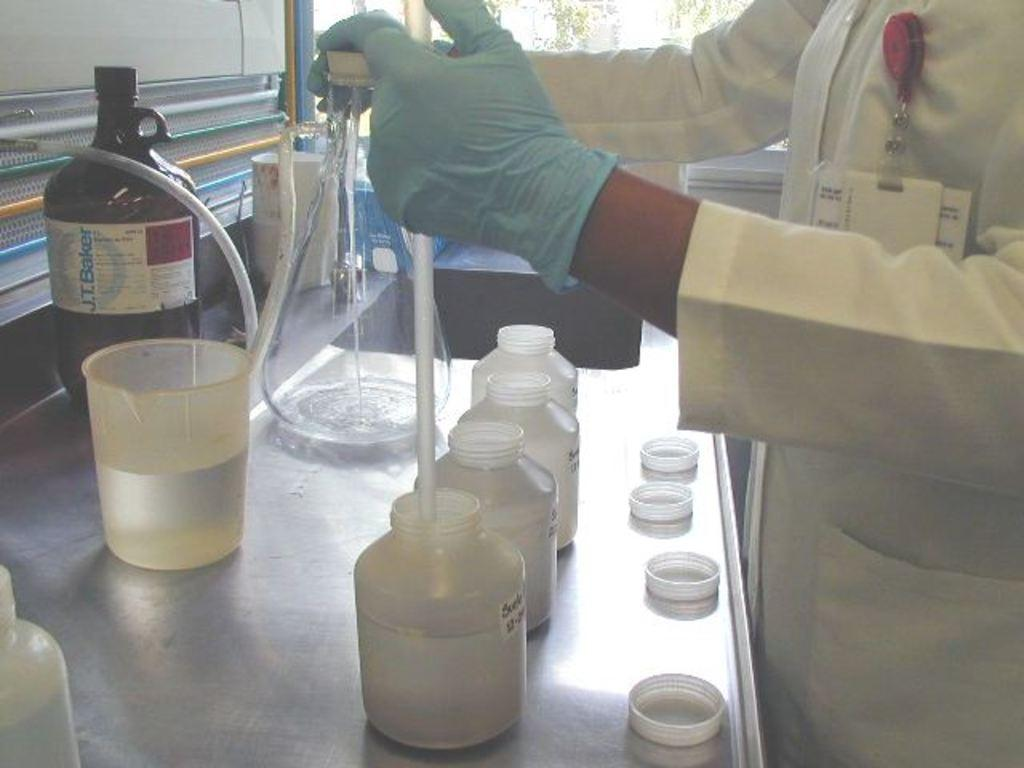<image>
Relay a brief, clear account of the picture shown. A person in a white coat does lab work while a brown bottle from J.T. Baker sits on the counter. 